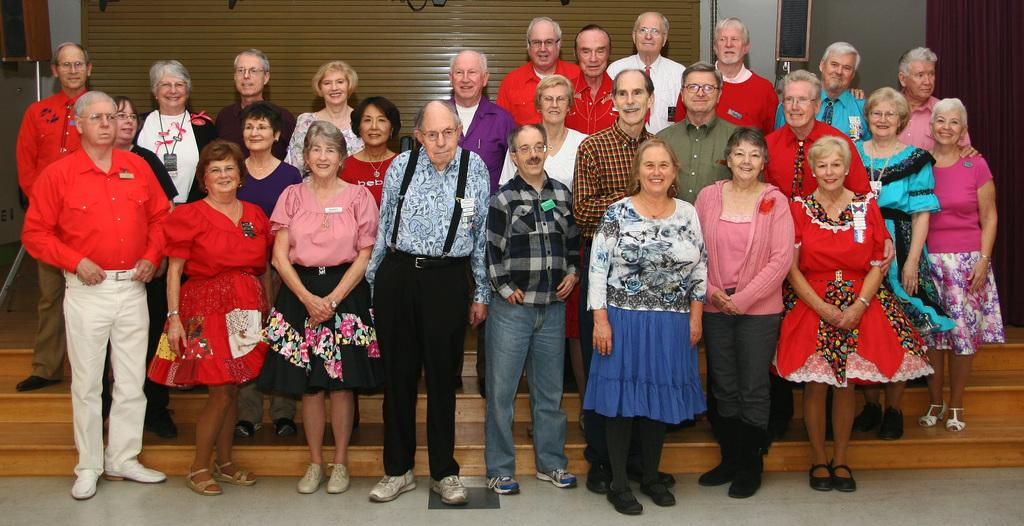Who is present in the image? There is an old man and old women in the image. What are the people doing in the image? The people are standing near the steps, and some of them are smiling. What can be seen in the background of the image? There is a wall with a shutter in the background. What type of volleyball game is being played in the image? There is no volleyball game present in the image. Can you tell me which person is playing the guitar in the image? There is no guitar or person playing it in the image. 